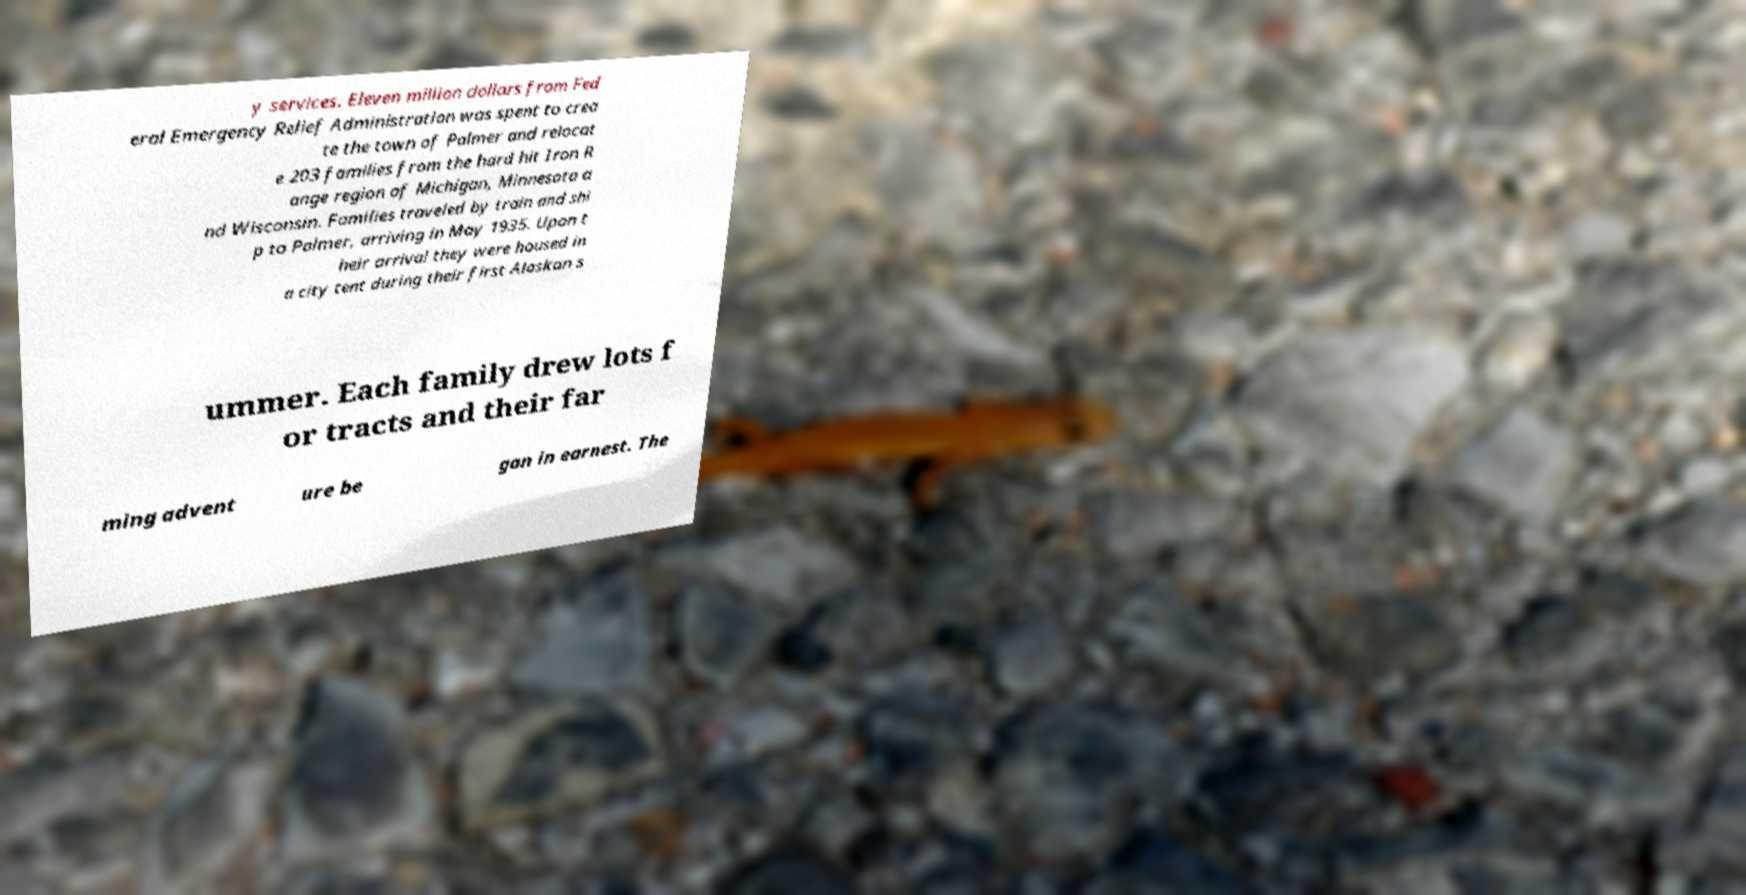Could you assist in decoding the text presented in this image and type it out clearly? y services. Eleven million dollars from Fed eral Emergency Relief Administration was spent to crea te the town of Palmer and relocat e 203 families from the hard hit Iron R ange region of Michigan, Minnesota a nd Wisconsin. Families traveled by train and shi p to Palmer, arriving in May 1935. Upon t heir arrival they were housed in a city tent during their first Alaskan s ummer. Each family drew lots f or tracts and their far ming advent ure be gan in earnest. The 